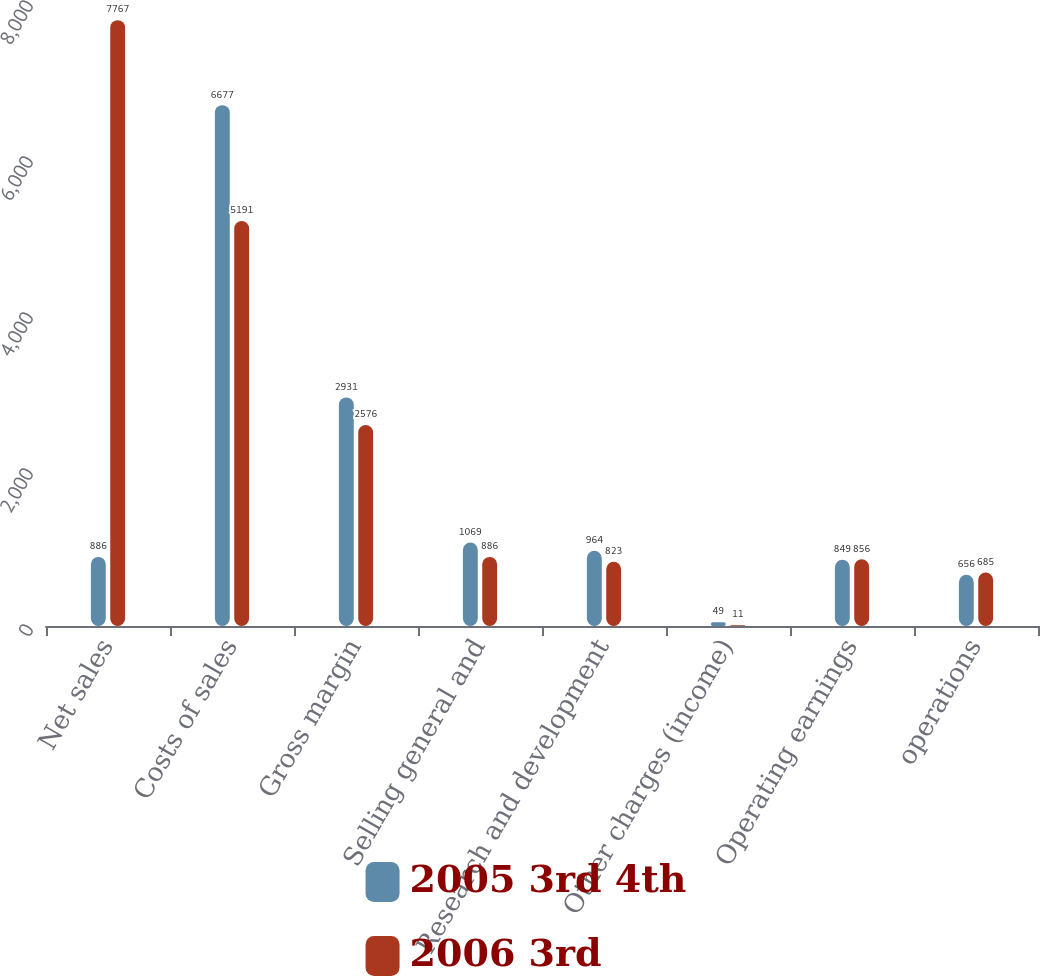Convert chart. <chart><loc_0><loc_0><loc_500><loc_500><stacked_bar_chart><ecel><fcel>Net sales<fcel>Costs of sales<fcel>Gross margin<fcel>Selling general and<fcel>Research and development<fcel>Other charges (income)<fcel>Operating earnings<fcel>operations<nl><fcel>2005 3rd 4th<fcel>886<fcel>6677<fcel>2931<fcel>1069<fcel>964<fcel>49<fcel>849<fcel>656<nl><fcel>2006 3rd<fcel>7767<fcel>5191<fcel>2576<fcel>886<fcel>823<fcel>11<fcel>856<fcel>685<nl></chart> 